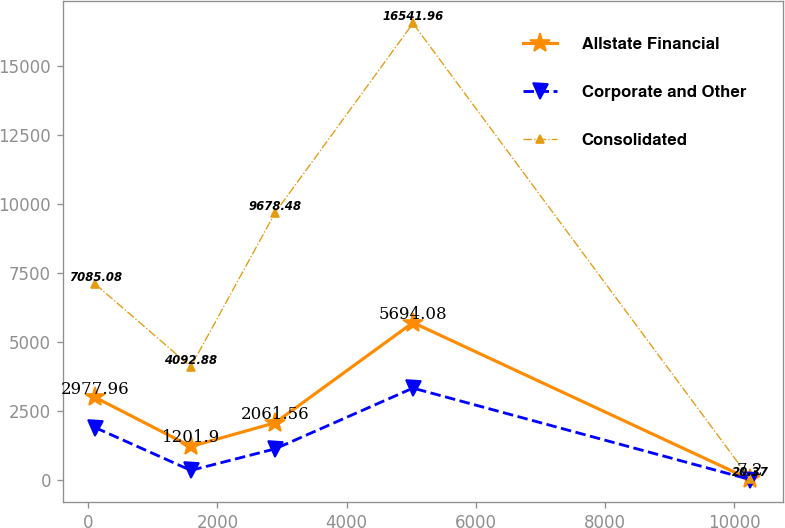<chart> <loc_0><loc_0><loc_500><loc_500><line_chart><ecel><fcel>Allstate Financial<fcel>Corporate and Other<fcel>Consolidated<nl><fcel>111.72<fcel>2977.96<fcel>1883.62<fcel>7085.08<nl><fcel>1589.41<fcel>1201.9<fcel>334.78<fcel>4092.88<nl><fcel>2894.54<fcel>2061.56<fcel>1115.64<fcel>9678.48<nl><fcel>5028.4<fcel>5694.08<fcel>3318.95<fcel>16542<nl><fcel>10249.3<fcel>7.2<fcel>3.2<fcel>20.37<nl></chart> 